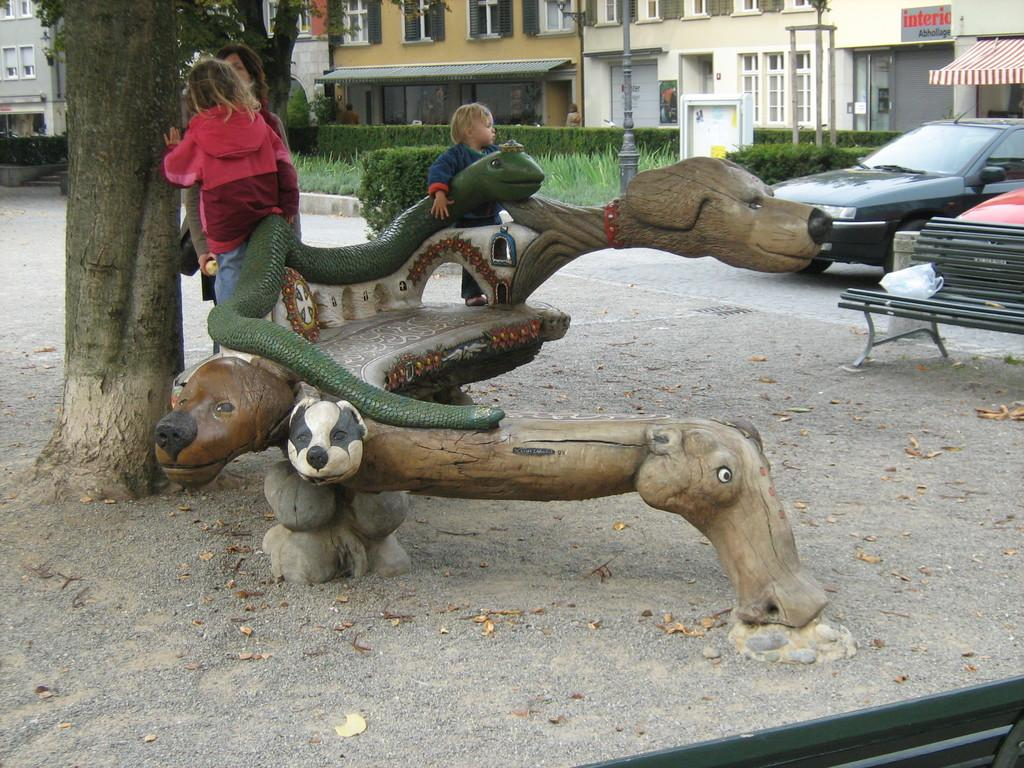Who is present in the image? There are children in the image. What object can be seen in the image that people might sit on? There is a bench in the image. What type of vehicles can be seen on the right side of the image? Cars are visible on the right side of the image. What can be seen in the distance in the image? There are buildings in the background of the image. What feeling is expressed by the page in the image? There is no page present in the image, so it is not possible to determine any feelings expressed by it. 